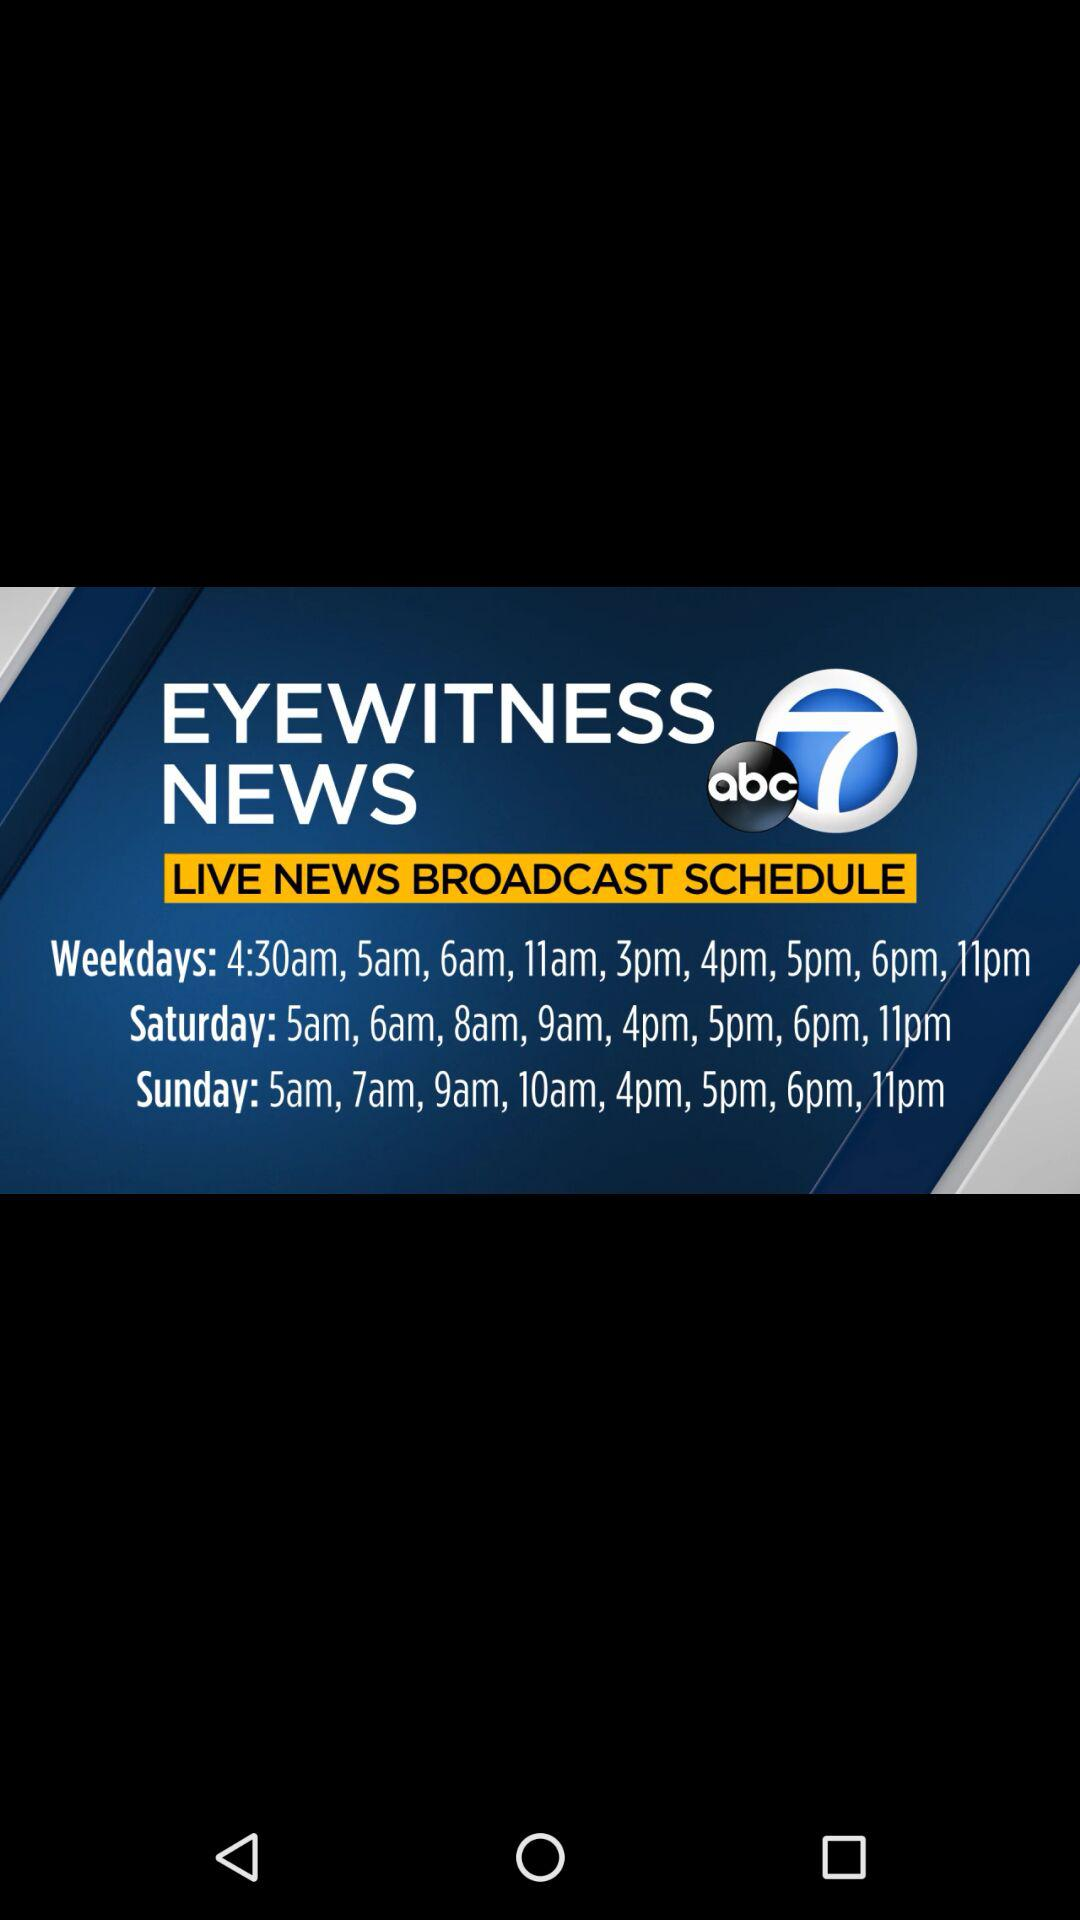What is the name of the application? The name of the application is "abc7". 